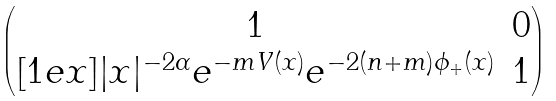<formula> <loc_0><loc_0><loc_500><loc_500>\begin{pmatrix} 1 & 0 \\ [ 1 e x ] | x | ^ { - 2 \alpha } e ^ { - m V ( x ) } e ^ { - 2 ( n + m ) \phi _ { + } ( x ) } & 1 \end{pmatrix}</formula> 